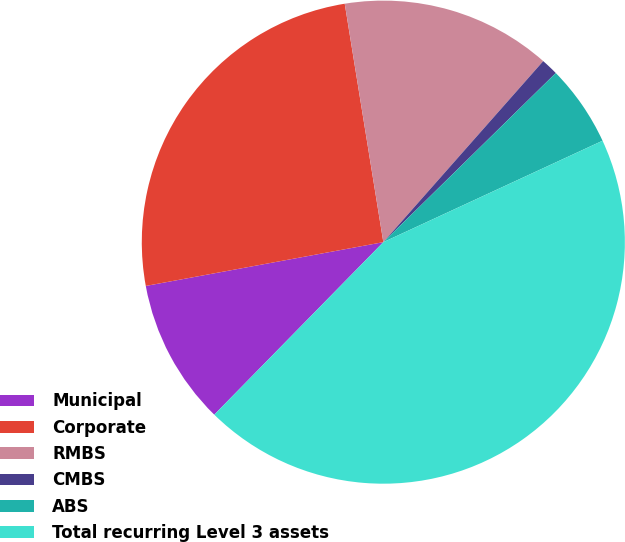Convert chart to OTSL. <chart><loc_0><loc_0><loc_500><loc_500><pie_chart><fcel>Municipal<fcel>Corporate<fcel>RMBS<fcel>CMBS<fcel>ABS<fcel>Total recurring Level 3 assets<nl><fcel>9.76%<fcel>25.35%<fcel>14.07%<fcel>1.14%<fcel>5.45%<fcel>44.24%<nl></chart> 